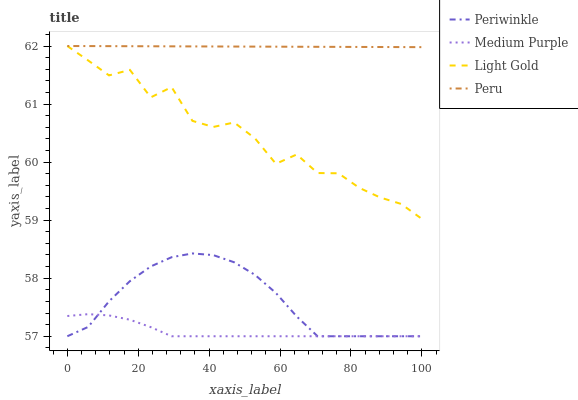Does Medium Purple have the minimum area under the curve?
Answer yes or no. Yes. Does Peru have the maximum area under the curve?
Answer yes or no. Yes. Does Light Gold have the minimum area under the curve?
Answer yes or no. No. Does Light Gold have the maximum area under the curve?
Answer yes or no. No. Is Peru the smoothest?
Answer yes or no. Yes. Is Light Gold the roughest?
Answer yes or no. Yes. Is Periwinkle the smoothest?
Answer yes or no. No. Is Periwinkle the roughest?
Answer yes or no. No. Does Light Gold have the lowest value?
Answer yes or no. No. Does Periwinkle have the highest value?
Answer yes or no. No. Is Medium Purple less than Light Gold?
Answer yes or no. Yes. Is Light Gold greater than Periwinkle?
Answer yes or no. Yes. Does Medium Purple intersect Light Gold?
Answer yes or no. No. 